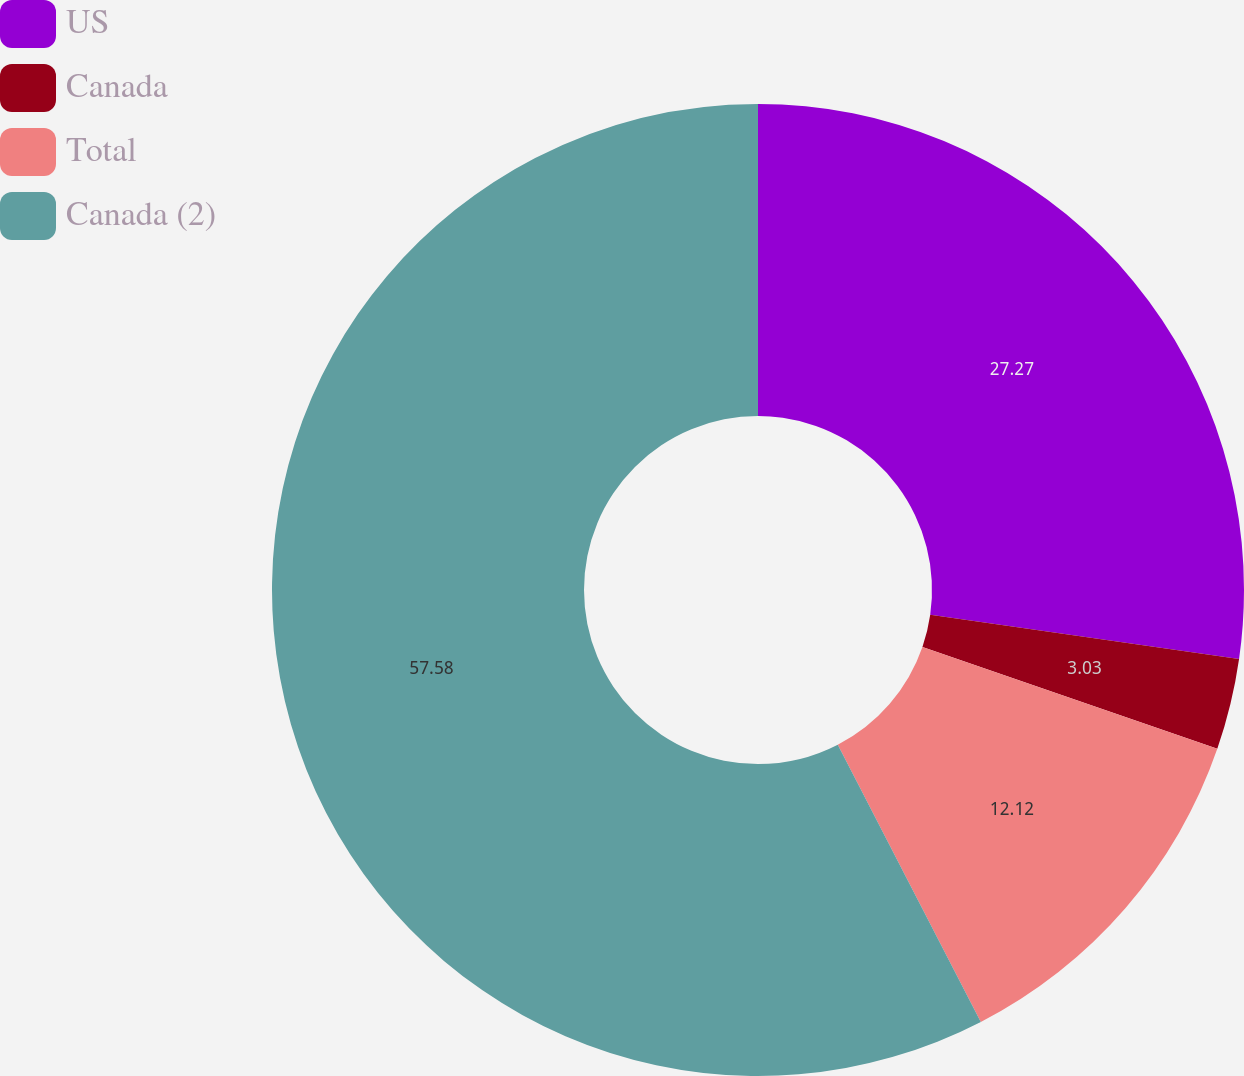Convert chart. <chart><loc_0><loc_0><loc_500><loc_500><pie_chart><fcel>US<fcel>Canada<fcel>Total<fcel>Canada (2)<nl><fcel>27.27%<fcel>3.03%<fcel>12.12%<fcel>57.58%<nl></chart> 